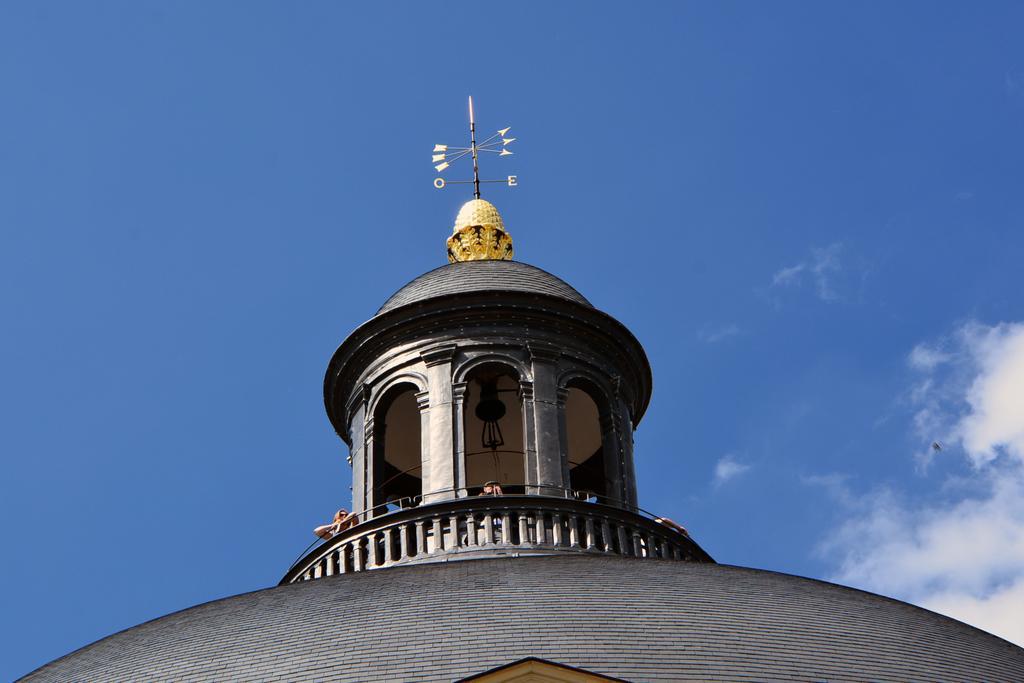In one or two sentences, can you explain what this image depicts? In this image we can see the tomb. Above the tomb there are directions. At the top there is the sky. There are few people standing under the tomb. 